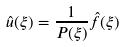Convert formula to latex. <formula><loc_0><loc_0><loc_500><loc_500>\hat { u } ( \xi ) = \frac { 1 } { P ( \xi ) } \hat { f } ( \xi )</formula> 